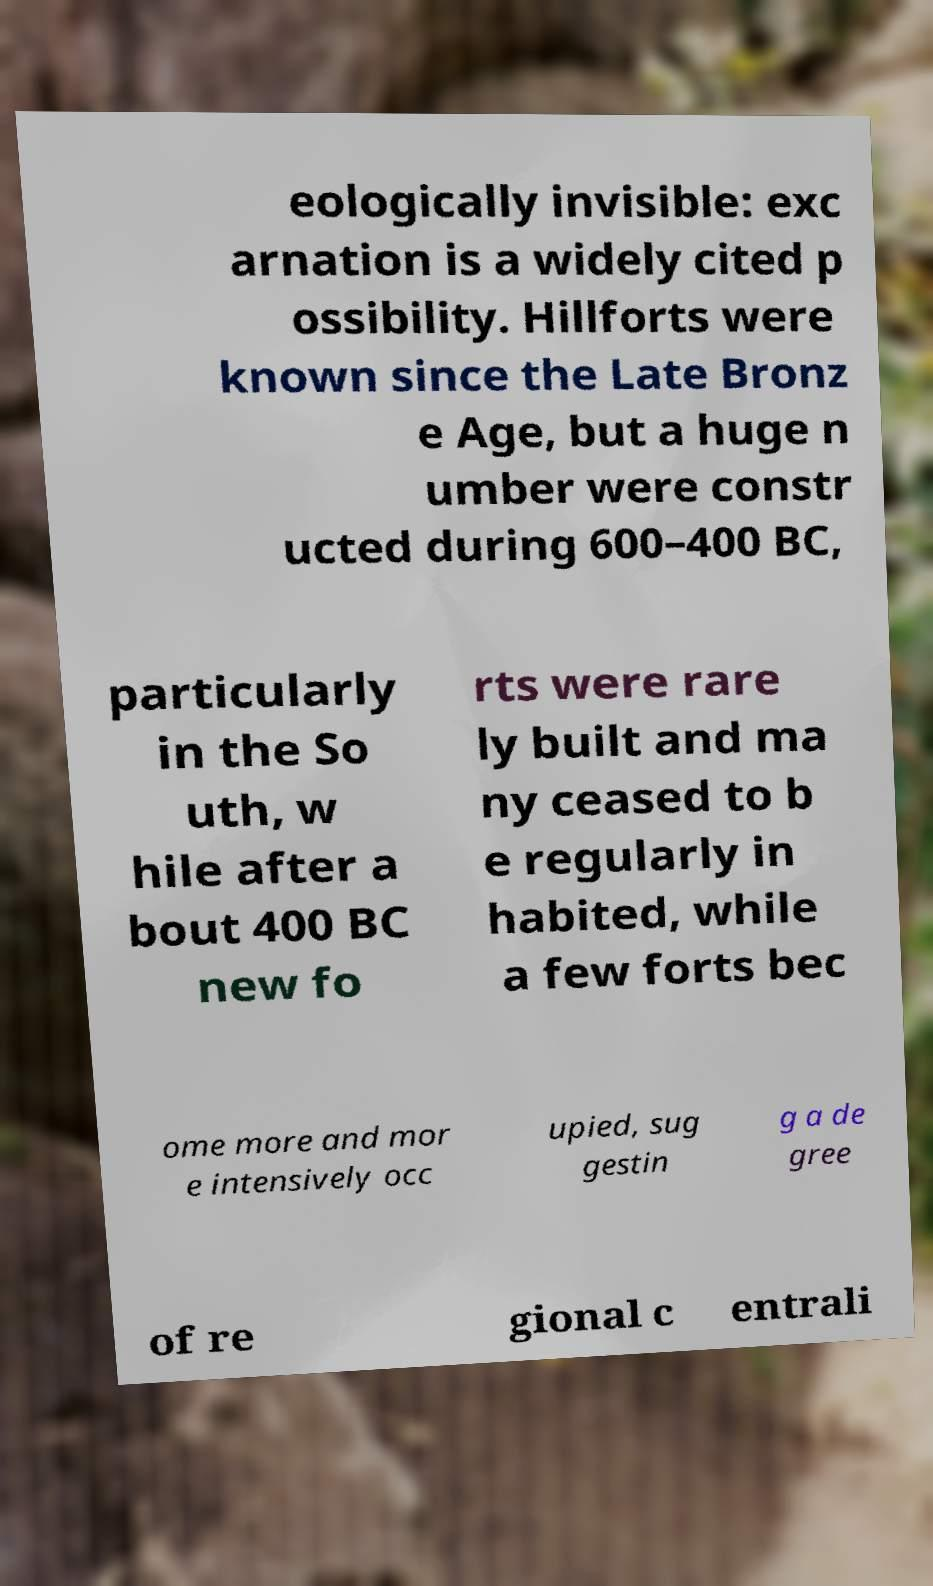There's text embedded in this image that I need extracted. Can you transcribe it verbatim? eologically invisible: exc arnation is a widely cited p ossibility. Hillforts were known since the Late Bronz e Age, but a huge n umber were constr ucted during 600–400 BC, particularly in the So uth, w hile after a bout 400 BC new fo rts were rare ly built and ma ny ceased to b e regularly in habited, while a few forts bec ome more and mor e intensively occ upied, sug gestin g a de gree of re gional c entrali 